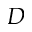<formula> <loc_0><loc_0><loc_500><loc_500>D</formula> 